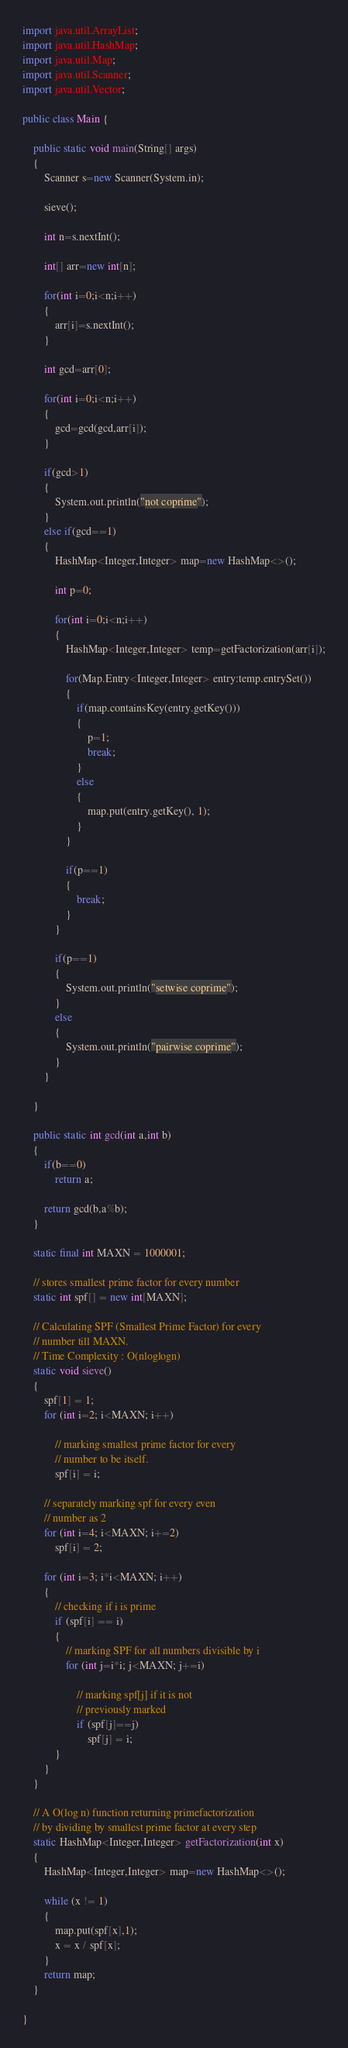Convert code to text. <code><loc_0><loc_0><loc_500><loc_500><_Java_>import java.util.ArrayList;
import java.util.HashMap;
import java.util.Map;
import java.util.Scanner;
import java.util.Vector;

public class Main {
	
	public static void main(String[] args)
	{
		Scanner s=new Scanner(System.in);
		
		sieve();
		
		int n=s.nextInt();
		
		int[] arr=new int[n];
		
		for(int i=0;i<n;i++)
		{
			arr[i]=s.nextInt();
		}
		
		int gcd=arr[0];
		
		for(int i=0;i<n;i++)
		{
			gcd=gcd(gcd,arr[i]);
		}
		
		if(gcd>1)
		{
			System.out.println("not coprime");
		}
		else if(gcd==1)
		{
			HashMap<Integer,Integer> map=new HashMap<>();
			
			int p=0;
			
			for(int i=0;i<n;i++)
			{
				HashMap<Integer,Integer> temp=getFactorization(arr[i]);
				
				for(Map.Entry<Integer,Integer> entry:temp.entrySet())
				{
					if(map.containsKey(entry.getKey()))
					{
						p=1;
						break;
					}
					else
					{
						map.put(entry.getKey(), 1);
					}
				}
				
				if(p==1)
				{
					break;
				}
			}
			
			if(p==1)
			{
				System.out.println("setwise coprime");
			}
			else
			{
				System.out.println("pairwise coprime");
			}
		}
		
	}
	
	public static int gcd(int a,int b)
	{
		if(b==0)
			return a;
		
		return gcd(b,a%b);
	}
	
	static final int MAXN = 1000001; 
    
    // stores smallest prime factor for every number 
    static int spf[] = new int[MAXN]; 
       
    // Calculating SPF (Smallest Prime Factor) for every 
    // number till MAXN. 
    // Time Complexity : O(nloglogn) 
    static void sieve() 
    { 
        spf[1] = 1; 
        for (int i=2; i<MAXN; i++) 
       
            // marking smallest prime factor for every 
            // number to be itself. 
            spf[i] = i; 
       
        // separately marking spf for every even 
        // number as 2 
        for (int i=4; i<MAXN; i+=2) 
            spf[i] = 2; 
       
        for (int i=3; i*i<MAXN; i++) 
        { 
            // checking if i is prime 
            if (spf[i] == i) 
            { 
                // marking SPF for all numbers divisible by i 
                for (int j=i*i; j<MAXN; j+=i) 
       
                    // marking spf[j] if it is not  
                    // previously marked 
                    if (spf[j]==j) 
                        spf[j] = i; 
            } 
        } 
    } 
       
    // A O(log n) function returning primefactorization 
    // by dividing by smallest prime factor at every step 
    static HashMap<Integer,Integer> getFactorization(int x) 
    { 
        HashMap<Integer,Integer> map=new HashMap<>();
        
        while (x != 1) 
        { 
            map.put(spf[x],1);
            x = x / spf[x]; 
        } 
        return map; 
    } 
	
}</code> 